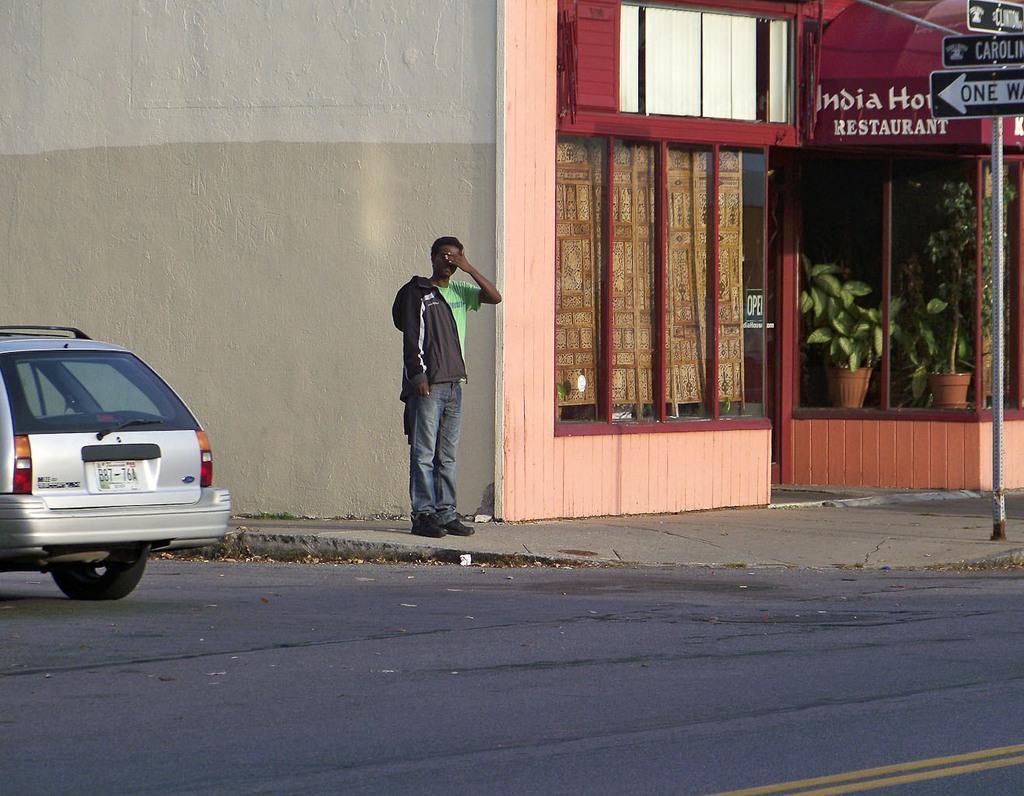In one or two sentences, can you explain what this image depicts? In this image I can see a person and car on the road. I can see a building,glass window,flower pots and boards and pole. I can see a white and cream color wall. 